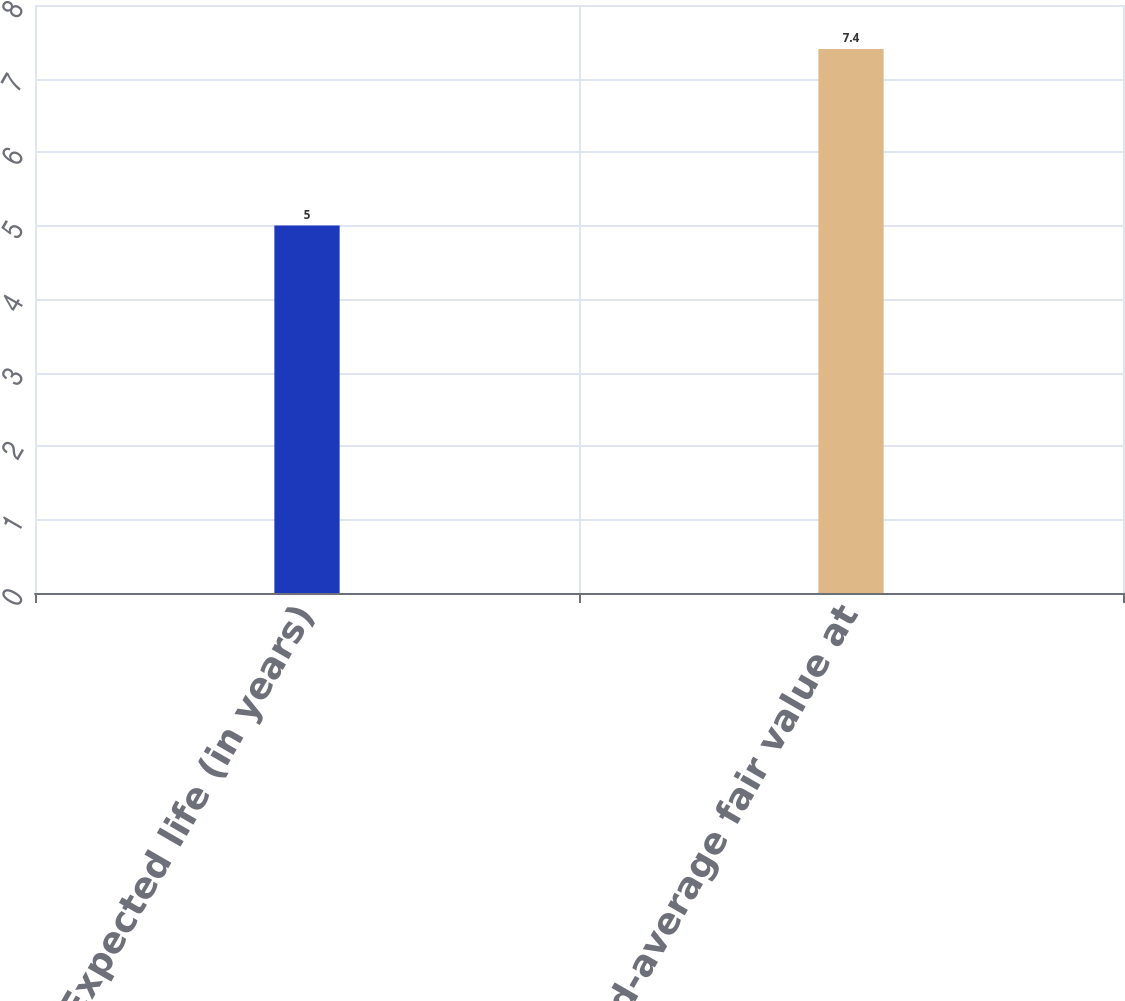Convert chart to OTSL. <chart><loc_0><loc_0><loc_500><loc_500><bar_chart><fcel>Expected life (in years)<fcel>Weighted-average fair value at<nl><fcel>5<fcel>7.4<nl></chart> 